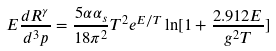Convert formula to latex. <formula><loc_0><loc_0><loc_500><loc_500>E \frac { d R ^ { \gamma } } { d ^ { 3 } p } = \frac { 5 \alpha \alpha _ { s } } { 1 8 \pi ^ { 2 } } T ^ { 2 } e ^ { E / T } \ln [ 1 + \frac { 2 . 9 1 2 E } { g ^ { 2 } T } ]</formula> 